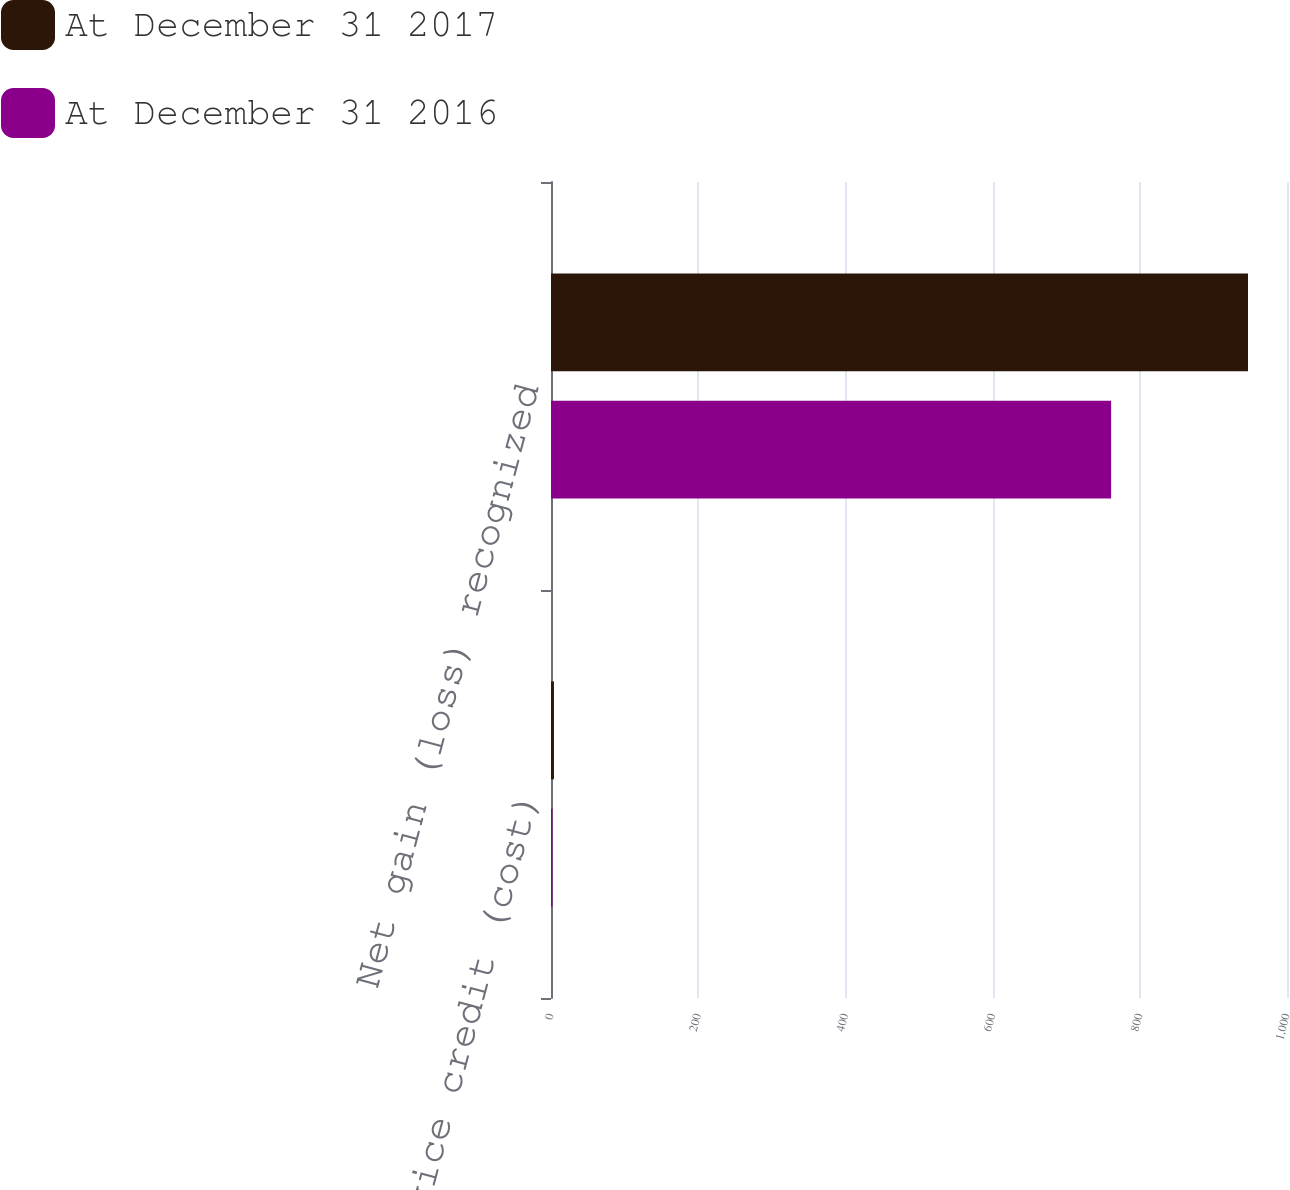<chart> <loc_0><loc_0><loc_500><loc_500><stacked_bar_chart><ecel><fcel>Prior service credit (cost)<fcel>Net gain (loss) recognized<nl><fcel>At December 31 2017<fcel>4<fcel>947<nl><fcel>At December 31 2016<fcel>2<fcel>761<nl></chart> 